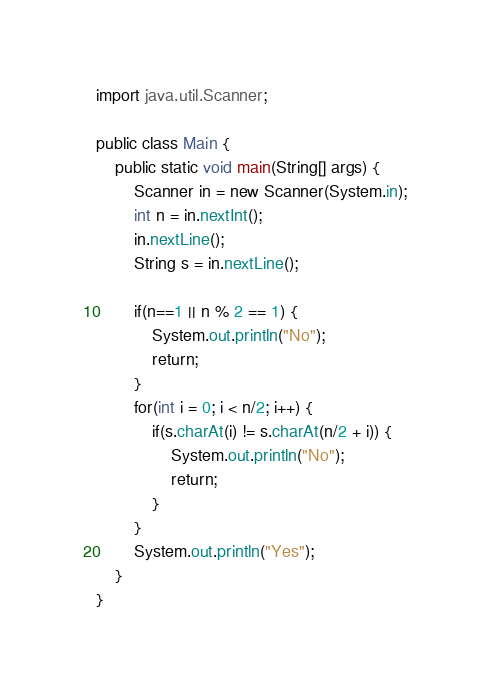Convert code to text. <code><loc_0><loc_0><loc_500><loc_500><_Java_>
import java.util.Scanner;

public class Main {
	public static void main(String[] args) {
		Scanner in = new Scanner(System.in);
		int n = in.nextInt();
		in.nextLine();
		String s = in.nextLine();

		if(n==1 || n % 2 == 1) {
			System.out.println("No");
			return;
		}
		for(int i = 0; i < n/2; i++) {
			if(s.charAt(i) != s.charAt(n/2 + i)) {
				System.out.println("No");
				return;
			}
		}
		System.out.println("Yes");
	}
}</code> 